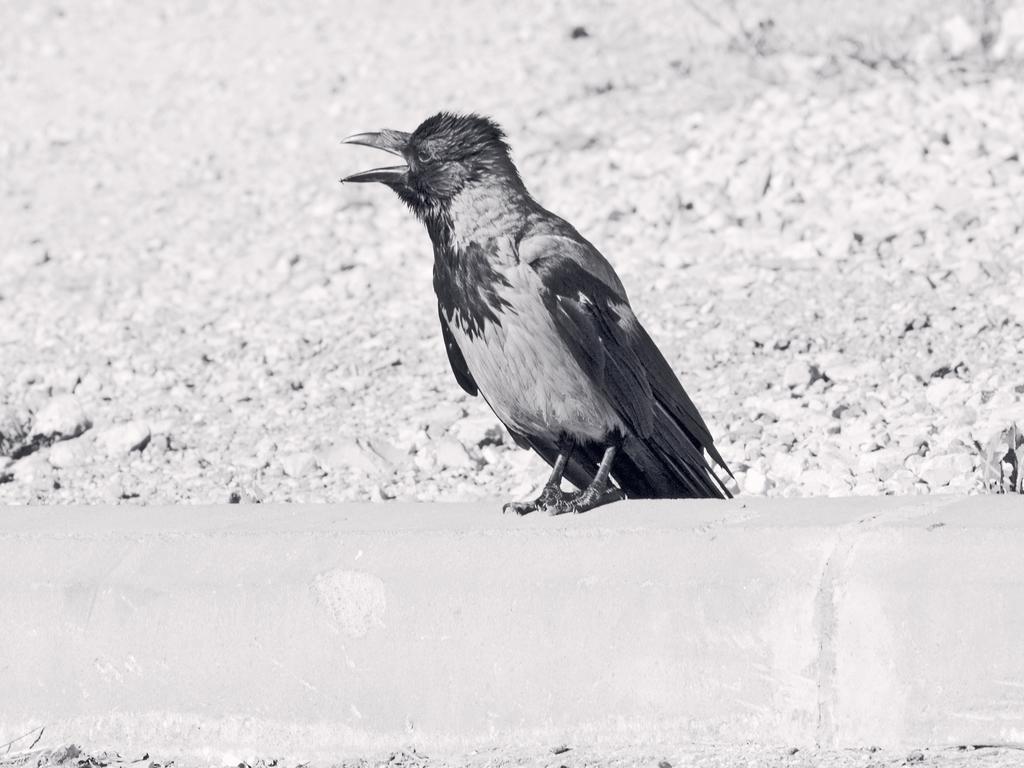How would you summarize this image in a sentence or two? This image is a black and white image. This image is taken outdoors. At the bottom of the image there is a divider on the ground. In the middle of the image there is a crow on the divider. In the background there is a ground with many pebbles. 